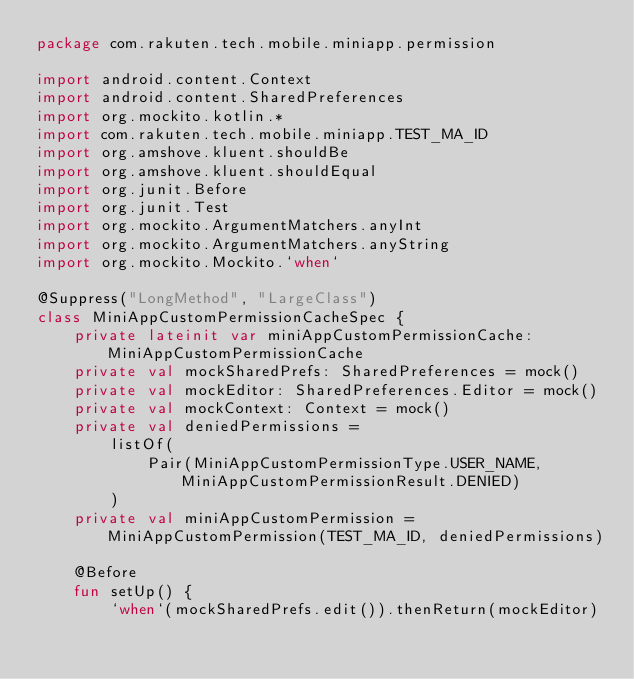Convert code to text. <code><loc_0><loc_0><loc_500><loc_500><_Kotlin_>package com.rakuten.tech.mobile.miniapp.permission

import android.content.Context
import android.content.SharedPreferences
import org.mockito.kotlin.*
import com.rakuten.tech.mobile.miniapp.TEST_MA_ID
import org.amshove.kluent.shouldBe
import org.amshove.kluent.shouldEqual
import org.junit.Before
import org.junit.Test
import org.mockito.ArgumentMatchers.anyInt
import org.mockito.ArgumentMatchers.anyString
import org.mockito.Mockito.`when`

@Suppress("LongMethod", "LargeClass")
class MiniAppCustomPermissionCacheSpec {
    private lateinit var miniAppCustomPermissionCache: MiniAppCustomPermissionCache
    private val mockSharedPrefs: SharedPreferences = mock()
    private val mockEditor: SharedPreferences.Editor = mock()
    private val mockContext: Context = mock()
    private val deniedPermissions =
        listOf(
            Pair(MiniAppCustomPermissionType.USER_NAME, MiniAppCustomPermissionResult.DENIED)
        )
    private val miniAppCustomPermission = MiniAppCustomPermission(TEST_MA_ID, deniedPermissions)

    @Before
    fun setUp() {
        `when`(mockSharedPrefs.edit()).thenReturn(mockEditor)</code> 